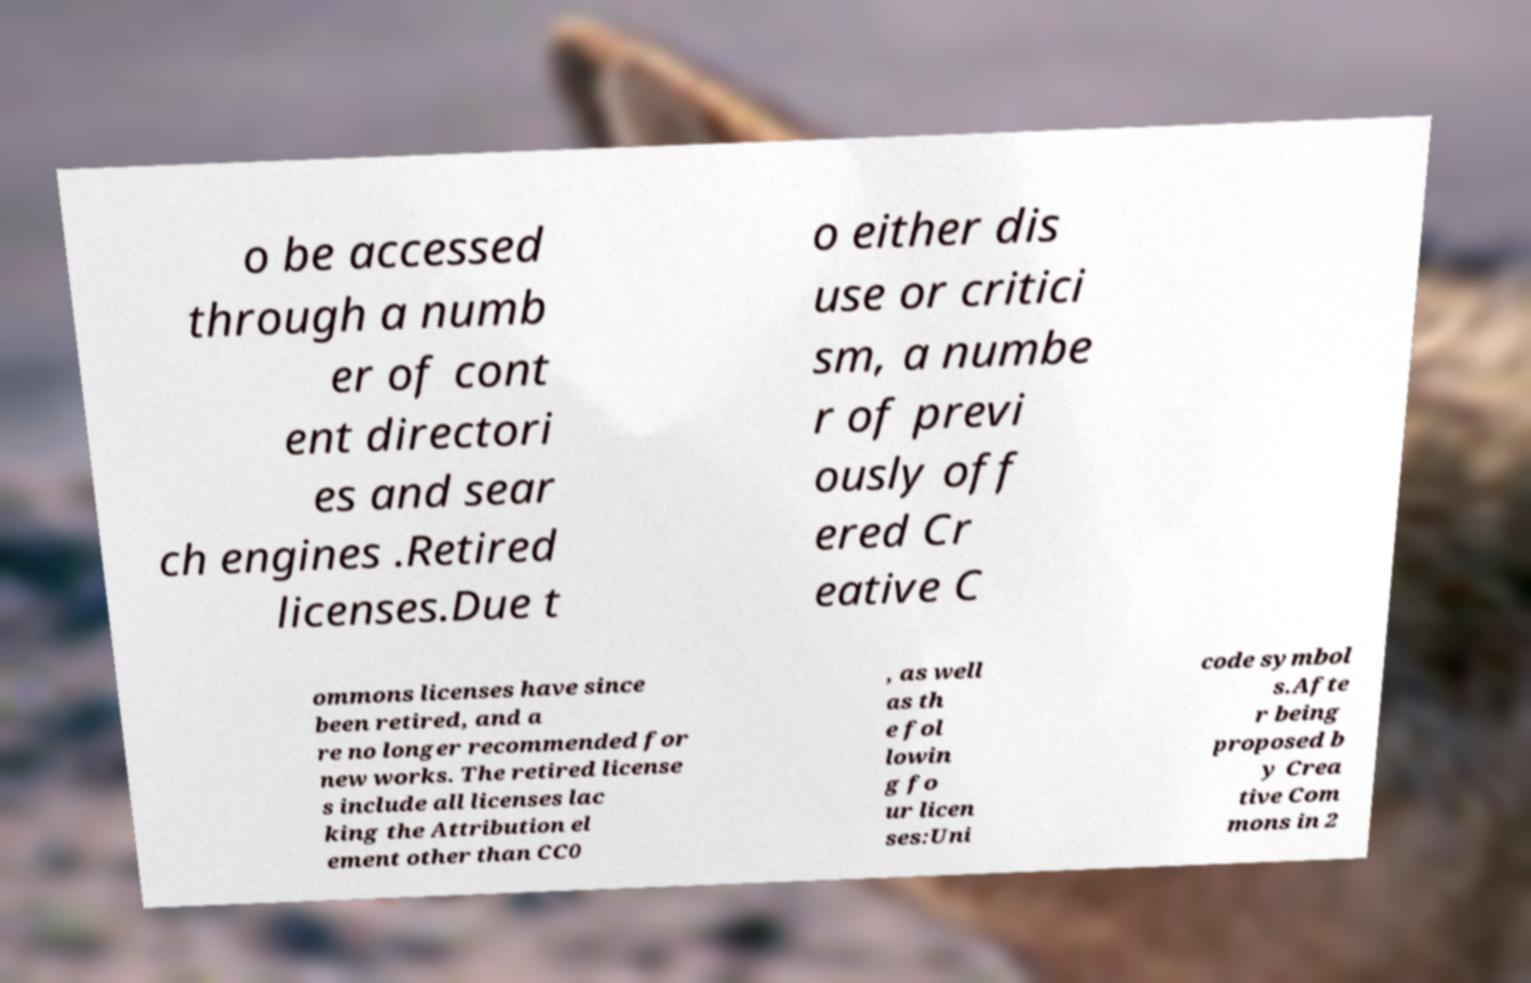Could you assist in decoding the text presented in this image and type it out clearly? o be accessed through a numb er of cont ent directori es and sear ch engines .Retired licenses.Due t o either dis use or critici sm, a numbe r of previ ously off ered Cr eative C ommons licenses have since been retired, and a re no longer recommended for new works. The retired license s include all licenses lac king the Attribution el ement other than CC0 , as well as th e fol lowin g fo ur licen ses:Uni code symbol s.Afte r being proposed b y Crea tive Com mons in 2 